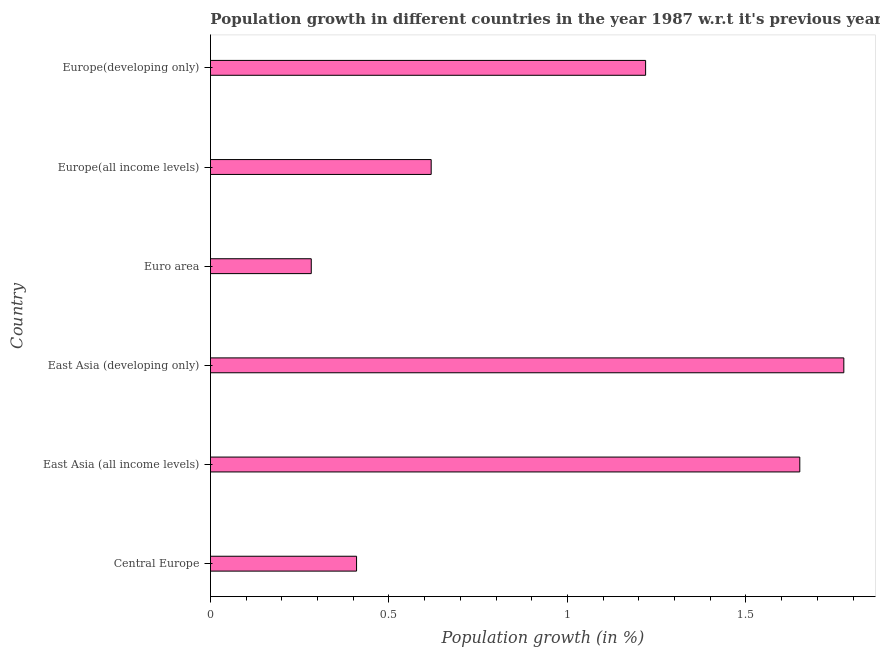What is the title of the graph?
Keep it short and to the point. Population growth in different countries in the year 1987 w.r.t it's previous year. What is the label or title of the X-axis?
Make the answer very short. Population growth (in %). What is the population growth in Euro area?
Provide a short and direct response. 0.28. Across all countries, what is the maximum population growth?
Provide a succinct answer. 1.77. Across all countries, what is the minimum population growth?
Provide a succinct answer. 0.28. In which country was the population growth maximum?
Make the answer very short. East Asia (developing only). What is the sum of the population growth?
Give a very brief answer. 5.95. What is the difference between the population growth in Central Europe and East Asia (all income levels)?
Your answer should be very brief. -1.24. What is the median population growth?
Your answer should be very brief. 0.92. What is the ratio of the population growth in Europe(all income levels) to that in Europe(developing only)?
Provide a succinct answer. 0.51. Is the population growth in East Asia (all income levels) less than that in East Asia (developing only)?
Ensure brevity in your answer.  Yes. Is the difference between the population growth in Central Europe and Euro area greater than the difference between any two countries?
Offer a terse response. No. What is the difference between the highest and the second highest population growth?
Offer a very short reply. 0.12. Is the sum of the population growth in Euro area and Europe(all income levels) greater than the maximum population growth across all countries?
Ensure brevity in your answer.  No. What is the difference between the highest and the lowest population growth?
Keep it short and to the point. 1.49. How many countries are there in the graph?
Make the answer very short. 6. What is the difference between two consecutive major ticks on the X-axis?
Your response must be concise. 0.5. What is the Population growth (in %) in Central Europe?
Your response must be concise. 0.41. What is the Population growth (in %) of East Asia (all income levels)?
Give a very brief answer. 1.65. What is the Population growth (in %) of East Asia (developing only)?
Provide a short and direct response. 1.77. What is the Population growth (in %) of Euro area?
Provide a short and direct response. 0.28. What is the Population growth (in %) in Europe(all income levels)?
Keep it short and to the point. 0.62. What is the Population growth (in %) of Europe(developing only)?
Your answer should be very brief. 1.22. What is the difference between the Population growth (in %) in Central Europe and East Asia (all income levels)?
Give a very brief answer. -1.24. What is the difference between the Population growth (in %) in Central Europe and East Asia (developing only)?
Provide a short and direct response. -1.36. What is the difference between the Population growth (in %) in Central Europe and Euro area?
Your answer should be compact. 0.13. What is the difference between the Population growth (in %) in Central Europe and Europe(all income levels)?
Your answer should be very brief. -0.21. What is the difference between the Population growth (in %) in Central Europe and Europe(developing only)?
Ensure brevity in your answer.  -0.81. What is the difference between the Population growth (in %) in East Asia (all income levels) and East Asia (developing only)?
Your answer should be very brief. -0.12. What is the difference between the Population growth (in %) in East Asia (all income levels) and Euro area?
Provide a short and direct response. 1.37. What is the difference between the Population growth (in %) in East Asia (all income levels) and Europe(all income levels)?
Offer a very short reply. 1.03. What is the difference between the Population growth (in %) in East Asia (all income levels) and Europe(developing only)?
Offer a terse response. 0.43. What is the difference between the Population growth (in %) in East Asia (developing only) and Euro area?
Offer a very short reply. 1.49. What is the difference between the Population growth (in %) in East Asia (developing only) and Europe(all income levels)?
Ensure brevity in your answer.  1.16. What is the difference between the Population growth (in %) in East Asia (developing only) and Europe(developing only)?
Your answer should be very brief. 0.56. What is the difference between the Population growth (in %) in Euro area and Europe(all income levels)?
Provide a short and direct response. -0.34. What is the difference between the Population growth (in %) in Euro area and Europe(developing only)?
Your answer should be compact. -0.94. What is the difference between the Population growth (in %) in Europe(all income levels) and Europe(developing only)?
Keep it short and to the point. -0.6. What is the ratio of the Population growth (in %) in Central Europe to that in East Asia (all income levels)?
Your response must be concise. 0.25. What is the ratio of the Population growth (in %) in Central Europe to that in East Asia (developing only)?
Offer a terse response. 0.23. What is the ratio of the Population growth (in %) in Central Europe to that in Euro area?
Ensure brevity in your answer.  1.45. What is the ratio of the Population growth (in %) in Central Europe to that in Europe(all income levels)?
Offer a terse response. 0.66. What is the ratio of the Population growth (in %) in Central Europe to that in Europe(developing only)?
Provide a short and direct response. 0.34. What is the ratio of the Population growth (in %) in East Asia (all income levels) to that in Euro area?
Your response must be concise. 5.85. What is the ratio of the Population growth (in %) in East Asia (all income levels) to that in Europe(all income levels)?
Your answer should be very brief. 2.67. What is the ratio of the Population growth (in %) in East Asia (all income levels) to that in Europe(developing only)?
Keep it short and to the point. 1.35. What is the ratio of the Population growth (in %) in East Asia (developing only) to that in Euro area?
Keep it short and to the point. 6.28. What is the ratio of the Population growth (in %) in East Asia (developing only) to that in Europe(all income levels)?
Ensure brevity in your answer.  2.87. What is the ratio of the Population growth (in %) in East Asia (developing only) to that in Europe(developing only)?
Provide a succinct answer. 1.46. What is the ratio of the Population growth (in %) in Euro area to that in Europe(all income levels)?
Give a very brief answer. 0.46. What is the ratio of the Population growth (in %) in Euro area to that in Europe(developing only)?
Ensure brevity in your answer.  0.23. What is the ratio of the Population growth (in %) in Europe(all income levels) to that in Europe(developing only)?
Provide a succinct answer. 0.51. 